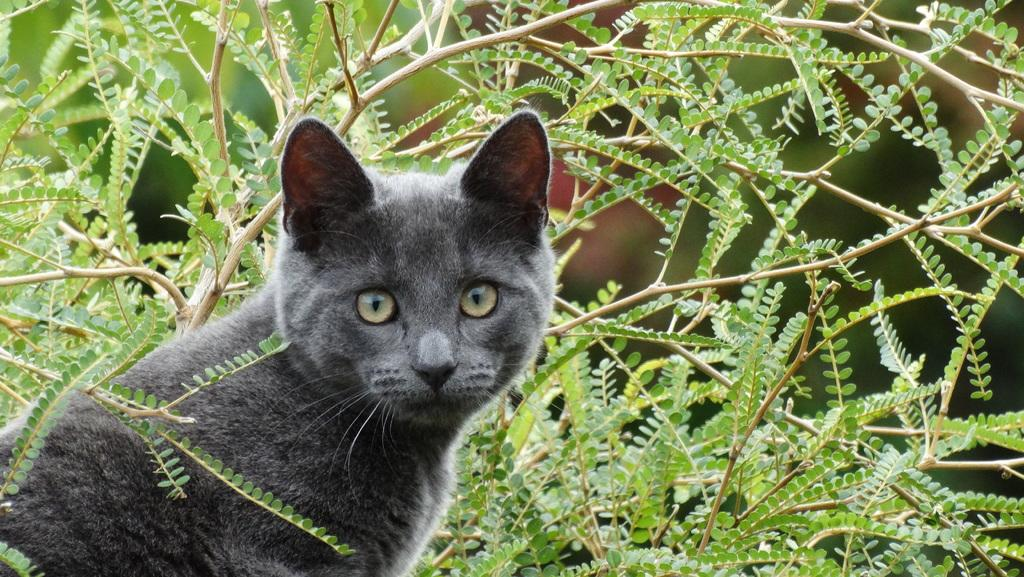What type of animal is in the image? There is a cat in the image. Where is the cat located in the image? The cat is on the left side of the image. What can be seen in the background or surrounding area of the image? There are leaves around the area of the image. What statement does the cat make in the image? The cat does not make a statement in the image, as it is a non-verbal animal. 